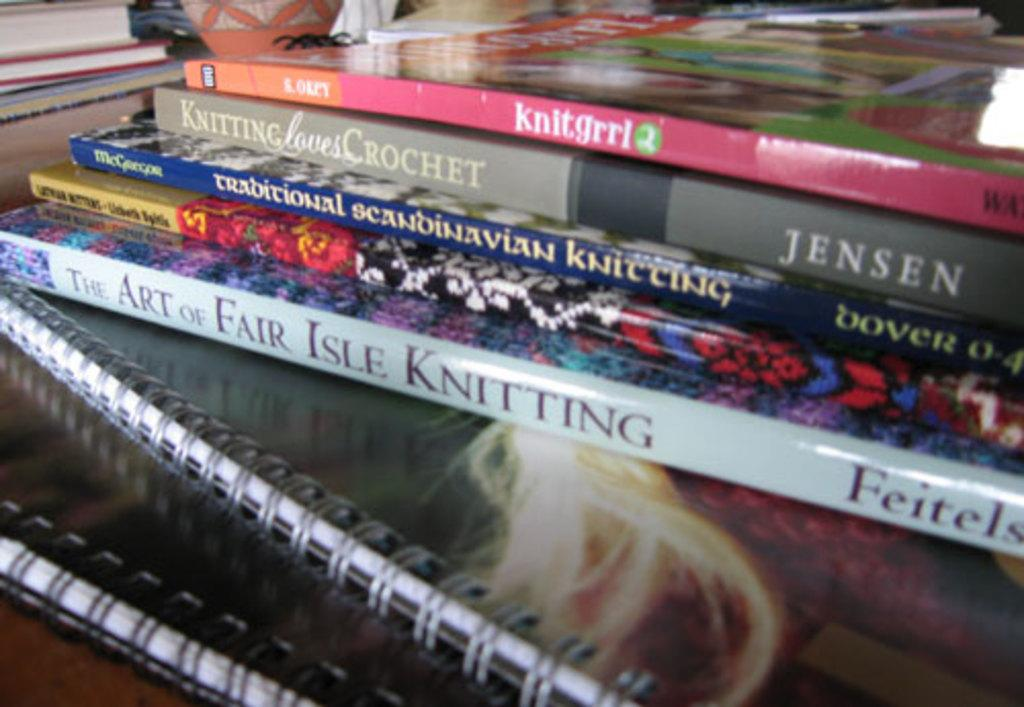Provide a one-sentence caption for the provided image. A book called Knit Grrl sits atop some other books about knitting. 